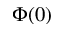Convert formula to latex. <formula><loc_0><loc_0><loc_500><loc_500>\Phi ( 0 )</formula> 